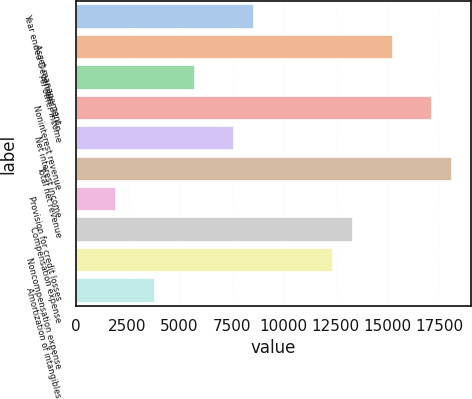<chart> <loc_0><loc_0><loc_500><loc_500><bar_chart><fcel>Year ended December 31 (in<fcel>Asset management<fcel>All other income<fcel>Noninterest revenue<fcel>Net interest income<fcel>Total net revenue<fcel>Provision for credit losses<fcel>Compensation expense<fcel>Noncompensation expense<fcel>Amortization of intangibles<nl><fcel>8591.2<fcel>15253.8<fcel>5735.8<fcel>17157.4<fcel>7639.4<fcel>18109.2<fcel>1928.6<fcel>13350.2<fcel>12398.4<fcel>3832.2<nl></chart> 